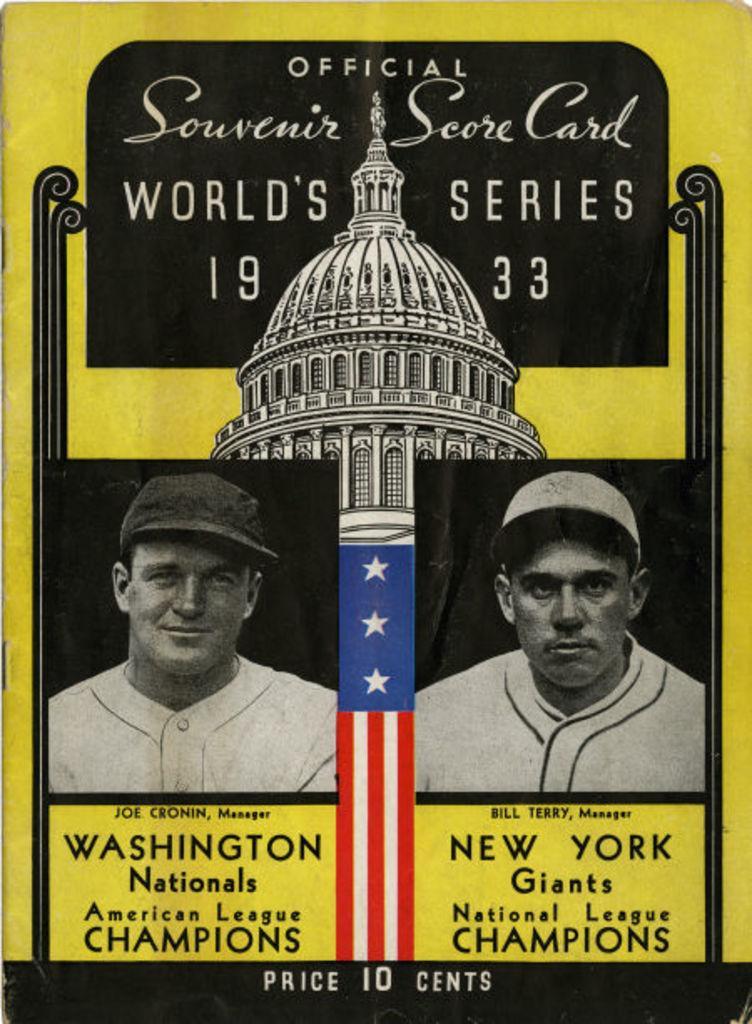Could you give a brief overview of what you see in this image? In this picture we can see a poster, in this poster we can see two men, they wore caps, we can also see a flag and a building, there is some text here. 